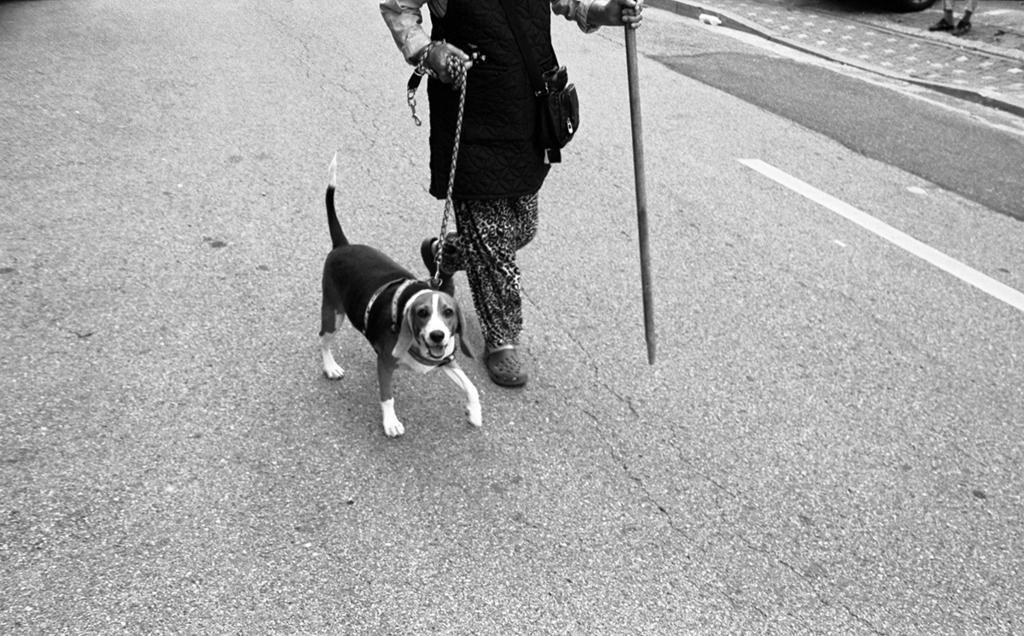Could you give a brief overview of what you see in this image? In this picture we can see a person and a dog walking here, the person is holding a stick and a chain, we can see strap on dog´s neck. 